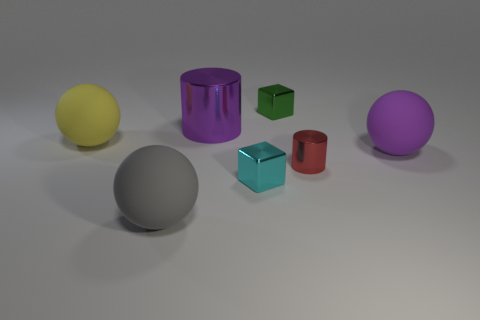Add 3 large green metal blocks. How many objects exist? 10 Subtract all cylinders. How many objects are left? 5 Add 7 large purple balls. How many large purple balls exist? 8 Subtract 1 purple balls. How many objects are left? 6 Subtract all large purple objects. Subtract all big purple spheres. How many objects are left? 4 Add 4 red shiny things. How many red shiny things are left? 5 